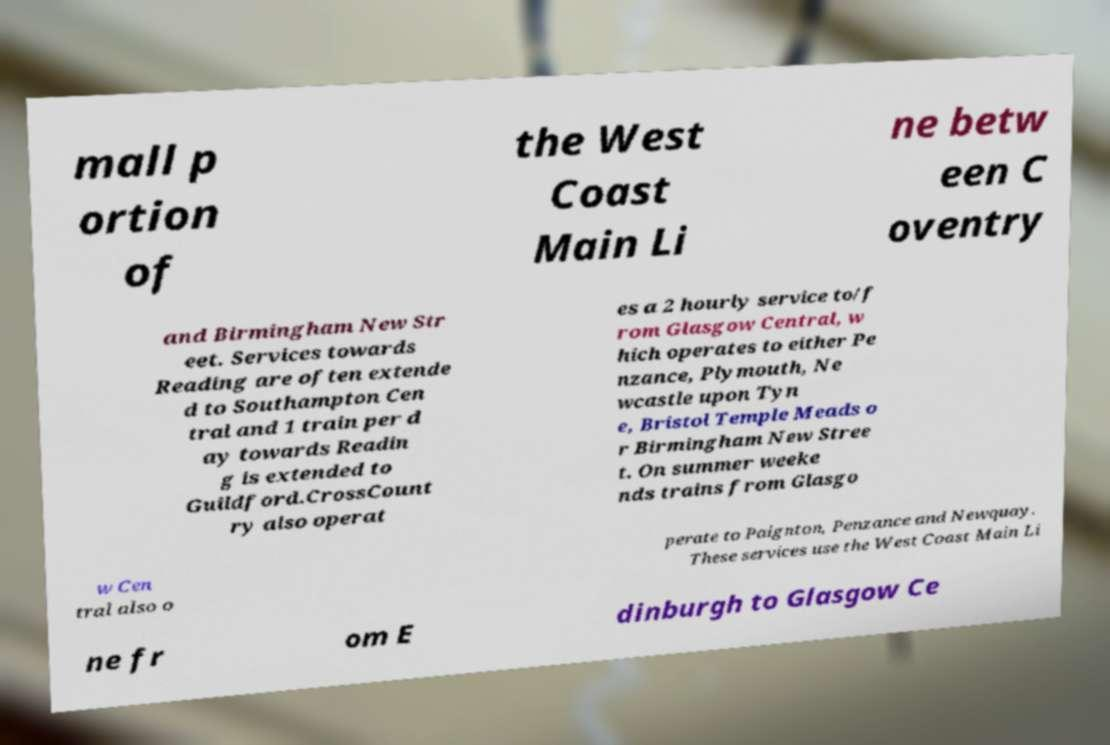Could you extract and type out the text from this image? mall p ortion of the West Coast Main Li ne betw een C oventry and Birmingham New Str eet. Services towards Reading are often extende d to Southampton Cen tral and 1 train per d ay towards Readin g is extended to Guildford.CrossCount ry also operat es a 2 hourly service to/f rom Glasgow Central, w hich operates to either Pe nzance, Plymouth, Ne wcastle upon Tyn e, Bristol Temple Meads o r Birmingham New Stree t. On summer weeke nds trains from Glasgo w Cen tral also o perate to Paignton, Penzance and Newquay. These services use the West Coast Main Li ne fr om E dinburgh to Glasgow Ce 